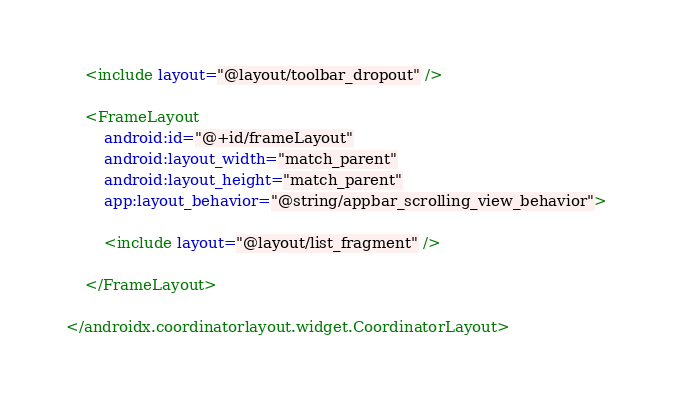<code> <loc_0><loc_0><loc_500><loc_500><_XML_>    <include layout="@layout/toolbar_dropout" />

    <FrameLayout
        android:id="@+id/frameLayout"
        android:layout_width="match_parent"
        android:layout_height="match_parent"
        app:layout_behavior="@string/appbar_scrolling_view_behavior">

        <include layout="@layout/list_fragment" />

    </FrameLayout>

</androidx.coordinatorlayout.widget.CoordinatorLayout>
</code> 